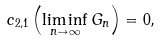<formula> <loc_0><loc_0><loc_500><loc_500>c _ { 2 , 1 } \left ( \liminf _ { n \to \infty } G _ { n } \right ) = 0 ,</formula> 